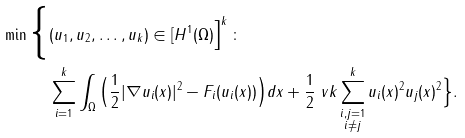<formula> <loc_0><loc_0><loc_500><loc_500>\min \Big \{ & ( u _ { 1 } , u _ { 2 } , \dots , u _ { k } ) \in [ H ^ { 1 } ( \Omega ) \Big ] ^ { k } \, \colon \, \\ & \sum _ { i = 1 } ^ { k } \int _ { \Omega } \Big ( \frac { 1 } { 2 } | \nabla u _ { i } ( x ) | ^ { 2 } - F _ { i } ( u _ { i } ( x ) ) \Big ) d x + \frac { 1 } { 2 } \ v k \sum _ { \substack { i , j = 1 \\ i \neq j } } ^ { k } u _ { i } ( x ) ^ { 2 } u _ { j } ( x ) ^ { 2 } \Big \} .</formula> 